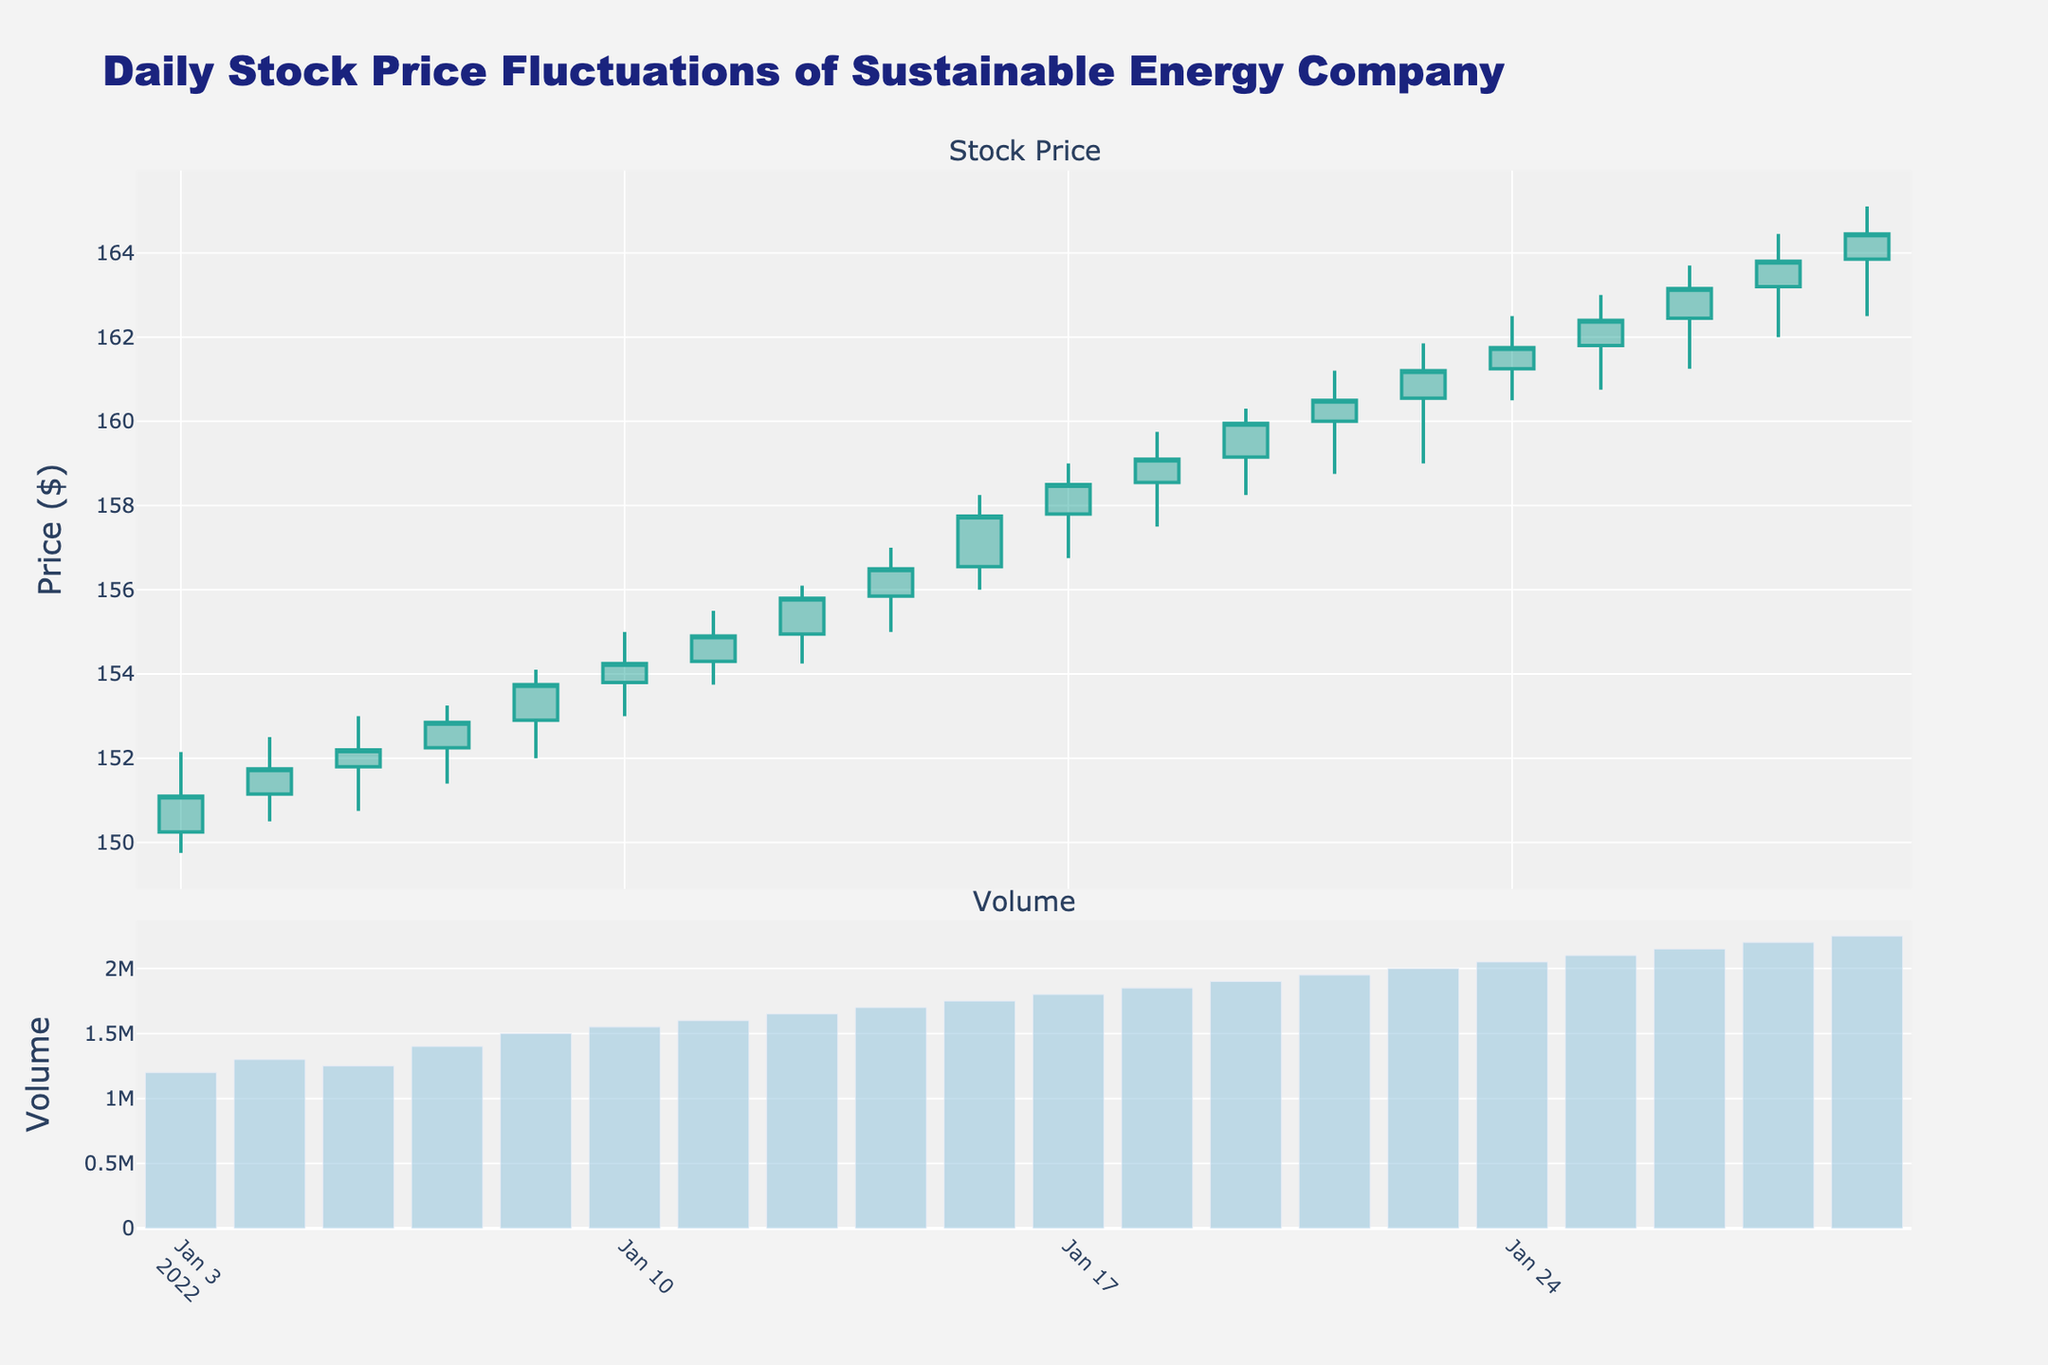What's the title of the figure? The title is usually displayed prominently at the top of the figure. It gives a brief description of the data being visualized. Look at the top of the figure to find the title.
Answer: Daily Stock Price Fluctuations of Sustainable Energy Company How many subplots are in the figure? The figure is divided into sections or subplots to represent different types of data. Identify the number of distinct visual sections vertically aligned.
Answer: 2 What information is shown in the first subplot? The first subplot typically includes the main visualization. Look at the labels, axes, and legend of the first part of the figure to determine what is being shown.
Answer: Stock Price What is represented by the bars in the second subplot? The second subplot usually complements the first by showing additional information. Identify what the bars represent by looking at the y-axis label on the second subplot.
Answer: Volume Between January 3 and January 28, on which date did the highest stock price occur? Examine the candlestick traces in the first subplot to find the date with the highest point on the "High" value of the stock price.
Answer: January 28 How did the closing price change from January 3 to January 28? By comparing the close prices on January 3 and January 28 from the candlestick chart, determine whether the stock price increased or decreased.
Answer: Increased What was the volume on January 14? Reference the bar on January 14 in the volume subplot to read the value.
Answer: 1,750,000 Which date had the highest trading volume? Look through the second subplot for the tallest bar and check the corresponding date on the x-axis.
Answer: January 28 What is the average closing price between January 3 and January 10? Sum the closing prices from January 3 to January 10 and divide by the number of trading days (6 in this case). (151.10 + 151.75 + 152.20 + 152.85 + 153.75 + 154.25) / 6
Answer: 152.65 Was there any date when the stock price did not change between the opening and closing? Review the candlestick chart for any dates where the opening and closing prices are the same.
Answer: No 